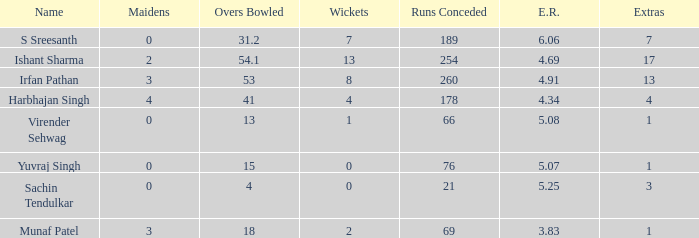Name the maaidens where overs bowled is 13 0.0. 